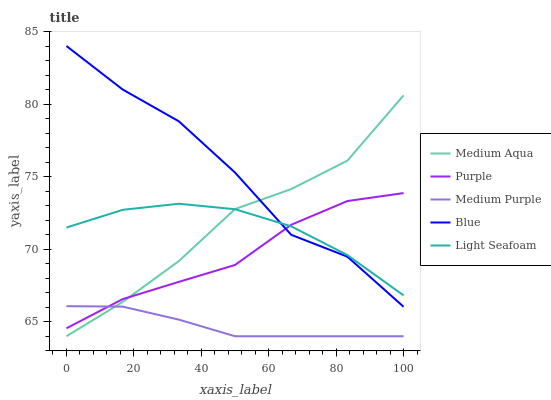Does Medium Purple have the minimum area under the curve?
Answer yes or no. Yes. Does Blue have the maximum area under the curve?
Answer yes or no. Yes. Does Light Seafoam have the minimum area under the curve?
Answer yes or no. No. Does Light Seafoam have the maximum area under the curve?
Answer yes or no. No. Is Medium Purple the smoothest?
Answer yes or no. Yes. Is Blue the roughest?
Answer yes or no. Yes. Is Light Seafoam the smoothest?
Answer yes or no. No. Is Light Seafoam the roughest?
Answer yes or no. No. Does Medium Purple have the lowest value?
Answer yes or no. Yes. Does Light Seafoam have the lowest value?
Answer yes or no. No. Does Blue have the highest value?
Answer yes or no. Yes. Does Light Seafoam have the highest value?
Answer yes or no. No. Is Medium Purple less than Light Seafoam?
Answer yes or no. Yes. Is Blue greater than Medium Purple?
Answer yes or no. Yes. Does Medium Purple intersect Purple?
Answer yes or no. Yes. Is Medium Purple less than Purple?
Answer yes or no. No. Is Medium Purple greater than Purple?
Answer yes or no. No. Does Medium Purple intersect Light Seafoam?
Answer yes or no. No. 